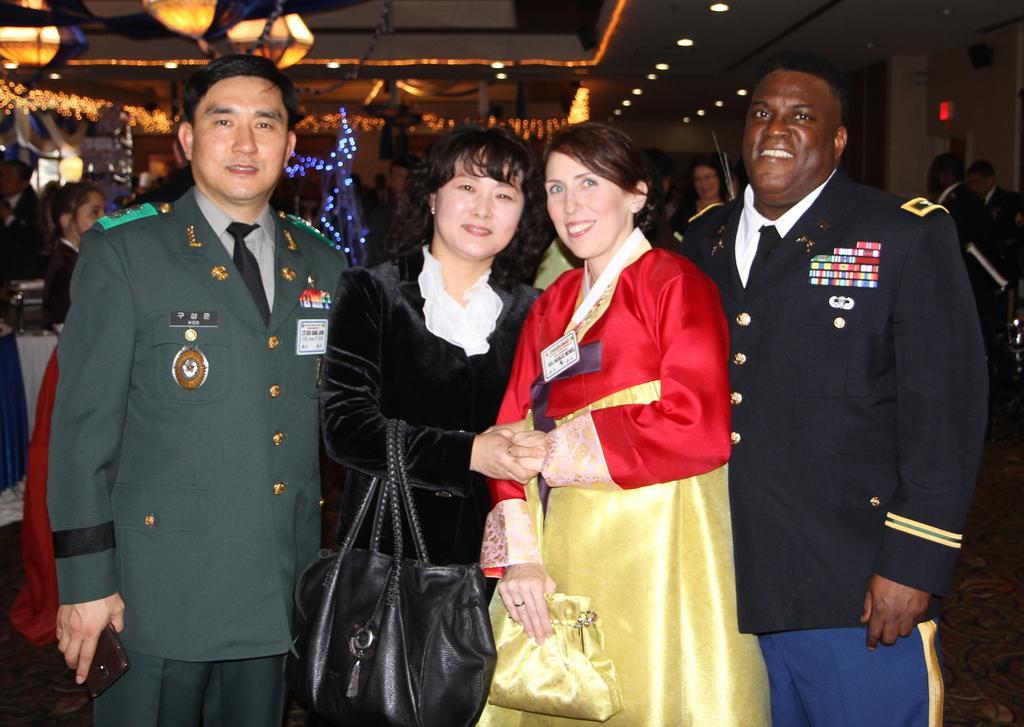Could you give a brief overview of what you see in this image? There are persons in different color dresses, smiling and standing. Two of them are holding handbags. In the background, there are other persons, there are lights attached to the roof and there are objects. And the background is dark in color. 